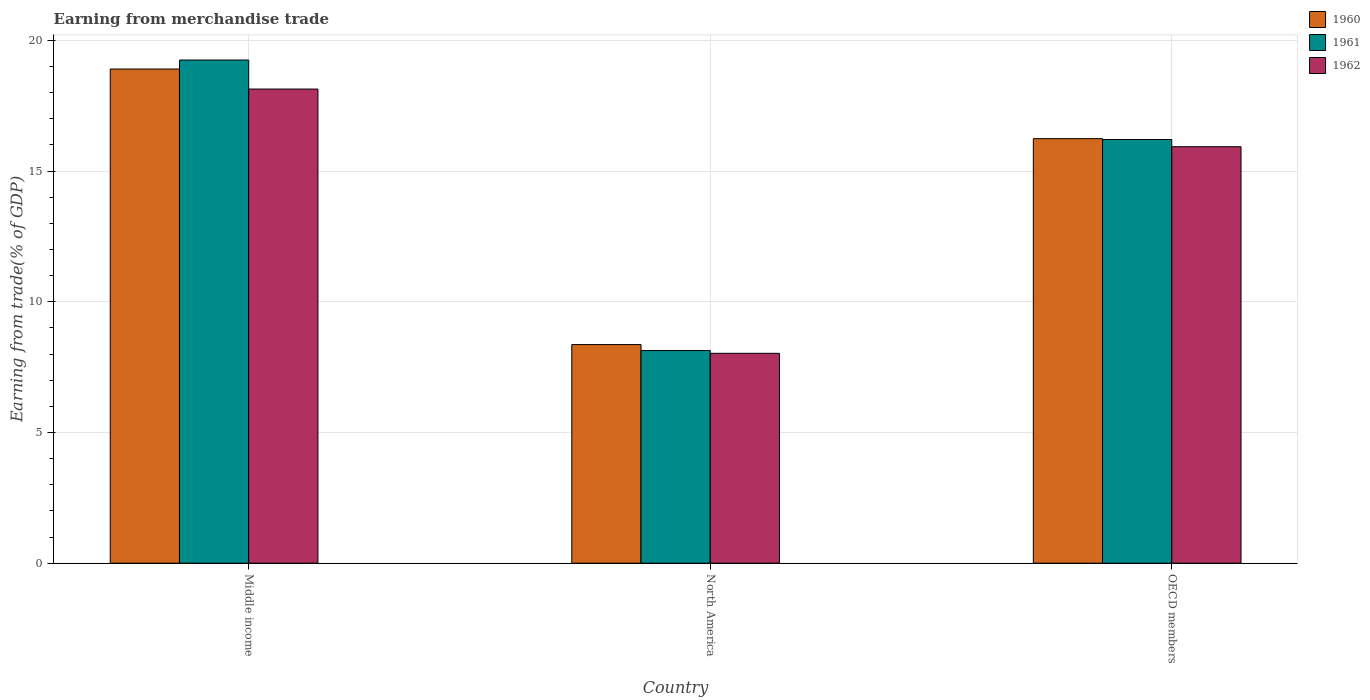How many different coloured bars are there?
Your answer should be very brief. 3. Are the number of bars per tick equal to the number of legend labels?
Ensure brevity in your answer.  Yes. How many bars are there on the 1st tick from the left?
Keep it short and to the point. 3. What is the label of the 1st group of bars from the left?
Your response must be concise. Middle income. In how many cases, is the number of bars for a given country not equal to the number of legend labels?
Make the answer very short. 0. What is the earnings from trade in 1961 in North America?
Your answer should be compact. 8.13. Across all countries, what is the maximum earnings from trade in 1961?
Provide a short and direct response. 19.25. Across all countries, what is the minimum earnings from trade in 1962?
Give a very brief answer. 8.03. In which country was the earnings from trade in 1962 minimum?
Offer a very short reply. North America. What is the total earnings from trade in 1961 in the graph?
Ensure brevity in your answer.  43.59. What is the difference between the earnings from trade in 1961 in North America and that in OECD members?
Provide a short and direct response. -8.07. What is the difference between the earnings from trade in 1960 in OECD members and the earnings from trade in 1961 in Middle income?
Offer a very short reply. -3.01. What is the average earnings from trade in 1961 per country?
Provide a succinct answer. 14.53. What is the difference between the earnings from trade of/in 1962 and earnings from trade of/in 1961 in Middle income?
Give a very brief answer. -1.11. What is the ratio of the earnings from trade in 1962 in Middle income to that in North America?
Offer a very short reply. 2.26. What is the difference between the highest and the second highest earnings from trade in 1960?
Give a very brief answer. 7.88. What is the difference between the highest and the lowest earnings from trade in 1960?
Your answer should be very brief. 10.54. In how many countries, is the earnings from trade in 1962 greater than the average earnings from trade in 1962 taken over all countries?
Offer a very short reply. 2. What does the 1st bar from the left in OECD members represents?
Your response must be concise. 1960. Is it the case that in every country, the sum of the earnings from trade in 1960 and earnings from trade in 1961 is greater than the earnings from trade in 1962?
Provide a short and direct response. Yes. How many bars are there?
Offer a very short reply. 9. How many countries are there in the graph?
Offer a very short reply. 3. What is the difference between two consecutive major ticks on the Y-axis?
Make the answer very short. 5. Does the graph contain grids?
Give a very brief answer. Yes. Where does the legend appear in the graph?
Your response must be concise. Top right. What is the title of the graph?
Provide a succinct answer. Earning from merchandise trade. What is the label or title of the X-axis?
Provide a short and direct response. Country. What is the label or title of the Y-axis?
Provide a short and direct response. Earning from trade(% of GDP). What is the Earning from trade(% of GDP) in 1960 in Middle income?
Keep it short and to the point. 18.9. What is the Earning from trade(% of GDP) of 1961 in Middle income?
Make the answer very short. 19.25. What is the Earning from trade(% of GDP) in 1962 in Middle income?
Offer a terse response. 18.14. What is the Earning from trade(% of GDP) in 1960 in North America?
Make the answer very short. 8.36. What is the Earning from trade(% of GDP) of 1961 in North America?
Your answer should be compact. 8.13. What is the Earning from trade(% of GDP) of 1962 in North America?
Provide a succinct answer. 8.03. What is the Earning from trade(% of GDP) of 1960 in OECD members?
Your answer should be very brief. 16.24. What is the Earning from trade(% of GDP) of 1961 in OECD members?
Your answer should be very brief. 16.21. What is the Earning from trade(% of GDP) of 1962 in OECD members?
Offer a terse response. 15.93. Across all countries, what is the maximum Earning from trade(% of GDP) in 1960?
Give a very brief answer. 18.9. Across all countries, what is the maximum Earning from trade(% of GDP) of 1961?
Your answer should be compact. 19.25. Across all countries, what is the maximum Earning from trade(% of GDP) of 1962?
Offer a very short reply. 18.14. Across all countries, what is the minimum Earning from trade(% of GDP) in 1960?
Make the answer very short. 8.36. Across all countries, what is the minimum Earning from trade(% of GDP) in 1961?
Offer a terse response. 8.13. Across all countries, what is the minimum Earning from trade(% of GDP) in 1962?
Keep it short and to the point. 8.03. What is the total Earning from trade(% of GDP) in 1960 in the graph?
Your answer should be very brief. 43.51. What is the total Earning from trade(% of GDP) of 1961 in the graph?
Keep it short and to the point. 43.59. What is the total Earning from trade(% of GDP) in 1962 in the graph?
Provide a succinct answer. 42.1. What is the difference between the Earning from trade(% of GDP) of 1960 in Middle income and that in North America?
Your response must be concise. 10.54. What is the difference between the Earning from trade(% of GDP) in 1961 in Middle income and that in North America?
Offer a very short reply. 11.11. What is the difference between the Earning from trade(% of GDP) in 1962 in Middle income and that in North America?
Keep it short and to the point. 10.11. What is the difference between the Earning from trade(% of GDP) in 1960 in Middle income and that in OECD members?
Offer a terse response. 2.66. What is the difference between the Earning from trade(% of GDP) of 1961 in Middle income and that in OECD members?
Offer a very short reply. 3.04. What is the difference between the Earning from trade(% of GDP) of 1962 in Middle income and that in OECD members?
Offer a terse response. 2.21. What is the difference between the Earning from trade(% of GDP) of 1960 in North America and that in OECD members?
Ensure brevity in your answer.  -7.88. What is the difference between the Earning from trade(% of GDP) in 1961 in North America and that in OECD members?
Keep it short and to the point. -8.07. What is the difference between the Earning from trade(% of GDP) of 1962 in North America and that in OECD members?
Ensure brevity in your answer.  -7.9. What is the difference between the Earning from trade(% of GDP) of 1960 in Middle income and the Earning from trade(% of GDP) of 1961 in North America?
Keep it short and to the point. 10.77. What is the difference between the Earning from trade(% of GDP) in 1960 in Middle income and the Earning from trade(% of GDP) in 1962 in North America?
Your response must be concise. 10.88. What is the difference between the Earning from trade(% of GDP) in 1961 in Middle income and the Earning from trade(% of GDP) in 1962 in North America?
Give a very brief answer. 11.22. What is the difference between the Earning from trade(% of GDP) in 1960 in Middle income and the Earning from trade(% of GDP) in 1961 in OECD members?
Your response must be concise. 2.7. What is the difference between the Earning from trade(% of GDP) in 1960 in Middle income and the Earning from trade(% of GDP) in 1962 in OECD members?
Your response must be concise. 2.97. What is the difference between the Earning from trade(% of GDP) of 1961 in Middle income and the Earning from trade(% of GDP) of 1962 in OECD members?
Ensure brevity in your answer.  3.32. What is the difference between the Earning from trade(% of GDP) in 1960 in North America and the Earning from trade(% of GDP) in 1961 in OECD members?
Provide a succinct answer. -7.84. What is the difference between the Earning from trade(% of GDP) in 1960 in North America and the Earning from trade(% of GDP) in 1962 in OECD members?
Offer a very short reply. -7.57. What is the difference between the Earning from trade(% of GDP) of 1961 in North America and the Earning from trade(% of GDP) of 1962 in OECD members?
Your answer should be very brief. -7.8. What is the average Earning from trade(% of GDP) of 1960 per country?
Your response must be concise. 14.5. What is the average Earning from trade(% of GDP) in 1961 per country?
Provide a succinct answer. 14.53. What is the average Earning from trade(% of GDP) of 1962 per country?
Your answer should be compact. 14.03. What is the difference between the Earning from trade(% of GDP) of 1960 and Earning from trade(% of GDP) of 1961 in Middle income?
Your response must be concise. -0.34. What is the difference between the Earning from trade(% of GDP) of 1960 and Earning from trade(% of GDP) of 1962 in Middle income?
Give a very brief answer. 0.77. What is the difference between the Earning from trade(% of GDP) in 1961 and Earning from trade(% of GDP) in 1962 in Middle income?
Give a very brief answer. 1.11. What is the difference between the Earning from trade(% of GDP) of 1960 and Earning from trade(% of GDP) of 1961 in North America?
Keep it short and to the point. 0.23. What is the difference between the Earning from trade(% of GDP) in 1960 and Earning from trade(% of GDP) in 1962 in North America?
Provide a short and direct response. 0.33. What is the difference between the Earning from trade(% of GDP) in 1961 and Earning from trade(% of GDP) in 1962 in North America?
Provide a short and direct response. 0.11. What is the difference between the Earning from trade(% of GDP) of 1960 and Earning from trade(% of GDP) of 1961 in OECD members?
Your response must be concise. 0.03. What is the difference between the Earning from trade(% of GDP) of 1960 and Earning from trade(% of GDP) of 1962 in OECD members?
Your answer should be very brief. 0.31. What is the difference between the Earning from trade(% of GDP) of 1961 and Earning from trade(% of GDP) of 1962 in OECD members?
Offer a very short reply. 0.28. What is the ratio of the Earning from trade(% of GDP) in 1960 in Middle income to that in North America?
Your answer should be compact. 2.26. What is the ratio of the Earning from trade(% of GDP) of 1961 in Middle income to that in North America?
Provide a succinct answer. 2.37. What is the ratio of the Earning from trade(% of GDP) in 1962 in Middle income to that in North America?
Keep it short and to the point. 2.26. What is the ratio of the Earning from trade(% of GDP) in 1960 in Middle income to that in OECD members?
Make the answer very short. 1.16. What is the ratio of the Earning from trade(% of GDP) in 1961 in Middle income to that in OECD members?
Offer a very short reply. 1.19. What is the ratio of the Earning from trade(% of GDP) of 1962 in Middle income to that in OECD members?
Give a very brief answer. 1.14. What is the ratio of the Earning from trade(% of GDP) in 1960 in North America to that in OECD members?
Give a very brief answer. 0.52. What is the ratio of the Earning from trade(% of GDP) in 1961 in North America to that in OECD members?
Offer a terse response. 0.5. What is the ratio of the Earning from trade(% of GDP) of 1962 in North America to that in OECD members?
Your response must be concise. 0.5. What is the difference between the highest and the second highest Earning from trade(% of GDP) of 1960?
Provide a short and direct response. 2.66. What is the difference between the highest and the second highest Earning from trade(% of GDP) of 1961?
Give a very brief answer. 3.04. What is the difference between the highest and the second highest Earning from trade(% of GDP) of 1962?
Provide a succinct answer. 2.21. What is the difference between the highest and the lowest Earning from trade(% of GDP) of 1960?
Your response must be concise. 10.54. What is the difference between the highest and the lowest Earning from trade(% of GDP) of 1961?
Provide a succinct answer. 11.11. What is the difference between the highest and the lowest Earning from trade(% of GDP) of 1962?
Your answer should be very brief. 10.11. 